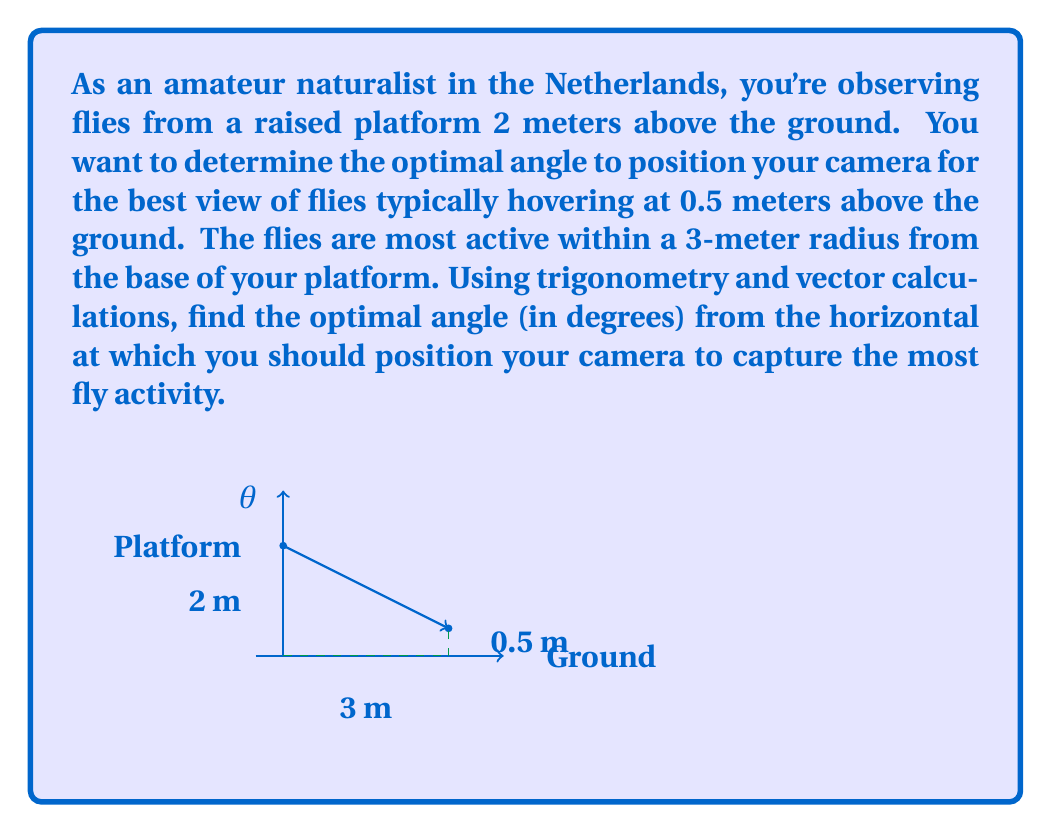Could you help me with this problem? Let's approach this problem step-by-step using trigonometry and vector calculations:

1) First, we need to identify the components of our vector:
   - Horizontal distance: 3 meters
   - Vertical distance: 2 - 0.5 = 1.5 meters (platform height minus fly height)

2) We can represent this as a vector $\vec{v} = \langle 3, -1.5 \rangle$

3) To find the angle this vector makes with the horizontal, we can use the arctangent function:

   $\theta = \arctan(\frac{y}{x}) = \arctan(\frac{-1.5}{3})$

4) However, we need to be careful here. The arctangent function returns values in radians, and we want our answer in degrees. Also, we want the angle from the horizontal downwards, which is the opposite of what arctangent gives us.

5) So, our final calculation will be:

   $\theta = -\arctan(\frac{-1.5}{3}) \cdot \frac{180}{\pi}$

6) Calculating this:
   $\theta \approx 26.57°$

This angle will allow your camera to be positioned optimally to capture the most fly activity within the specified range.
Answer: $26.57°$ 